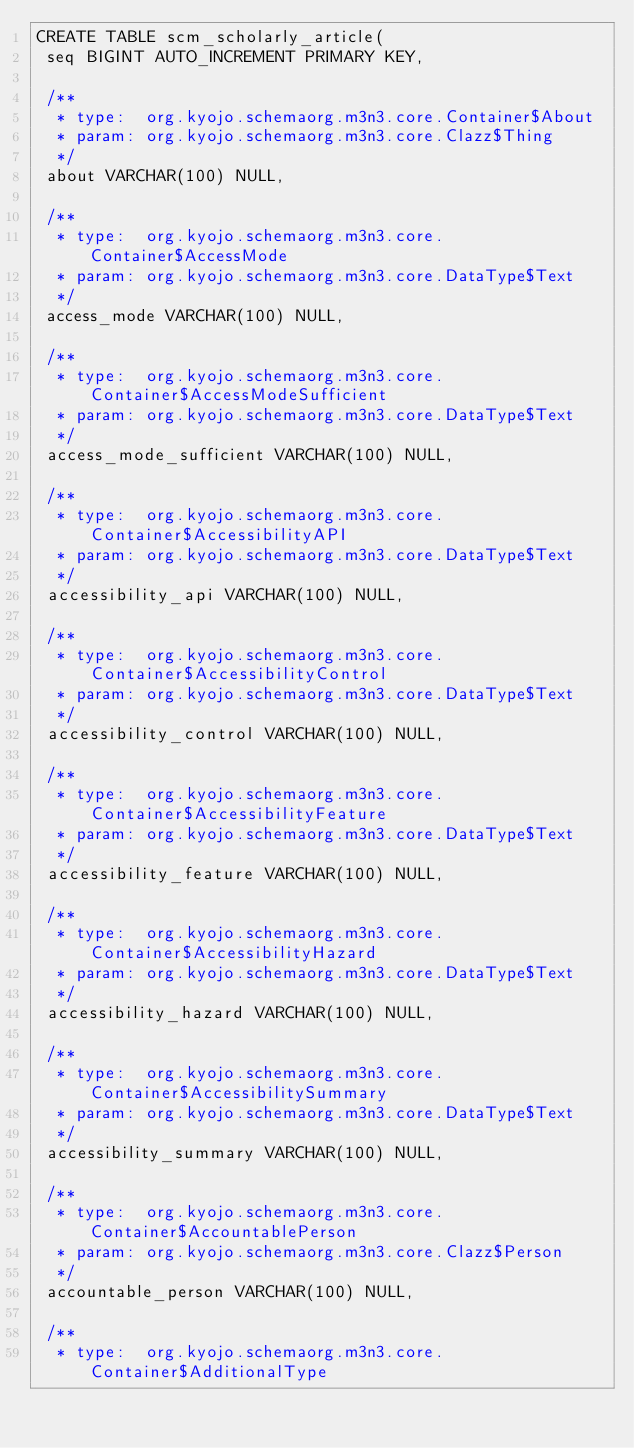<code> <loc_0><loc_0><loc_500><loc_500><_SQL_>CREATE TABLE scm_scholarly_article(
 seq BIGINT AUTO_INCREMENT PRIMARY KEY,

 /**
  * type:  org.kyojo.schemaorg.m3n3.core.Container$About
  * param: org.kyojo.schemaorg.m3n3.core.Clazz$Thing
  */
 about VARCHAR(100) NULL,

 /**
  * type:  org.kyojo.schemaorg.m3n3.core.Container$AccessMode
  * param: org.kyojo.schemaorg.m3n3.core.DataType$Text
  */
 access_mode VARCHAR(100) NULL,

 /**
  * type:  org.kyojo.schemaorg.m3n3.core.Container$AccessModeSufficient
  * param: org.kyojo.schemaorg.m3n3.core.DataType$Text
  */
 access_mode_sufficient VARCHAR(100) NULL,

 /**
  * type:  org.kyojo.schemaorg.m3n3.core.Container$AccessibilityAPI
  * param: org.kyojo.schemaorg.m3n3.core.DataType$Text
  */
 accessibility_api VARCHAR(100) NULL,

 /**
  * type:  org.kyojo.schemaorg.m3n3.core.Container$AccessibilityControl
  * param: org.kyojo.schemaorg.m3n3.core.DataType$Text
  */
 accessibility_control VARCHAR(100) NULL,

 /**
  * type:  org.kyojo.schemaorg.m3n3.core.Container$AccessibilityFeature
  * param: org.kyojo.schemaorg.m3n3.core.DataType$Text
  */
 accessibility_feature VARCHAR(100) NULL,

 /**
  * type:  org.kyojo.schemaorg.m3n3.core.Container$AccessibilityHazard
  * param: org.kyojo.schemaorg.m3n3.core.DataType$Text
  */
 accessibility_hazard VARCHAR(100) NULL,

 /**
  * type:  org.kyojo.schemaorg.m3n3.core.Container$AccessibilitySummary
  * param: org.kyojo.schemaorg.m3n3.core.DataType$Text
  */
 accessibility_summary VARCHAR(100) NULL,

 /**
  * type:  org.kyojo.schemaorg.m3n3.core.Container$AccountablePerson
  * param: org.kyojo.schemaorg.m3n3.core.Clazz$Person
  */
 accountable_person VARCHAR(100) NULL,

 /**
  * type:  org.kyojo.schemaorg.m3n3.core.Container$AdditionalType</code> 